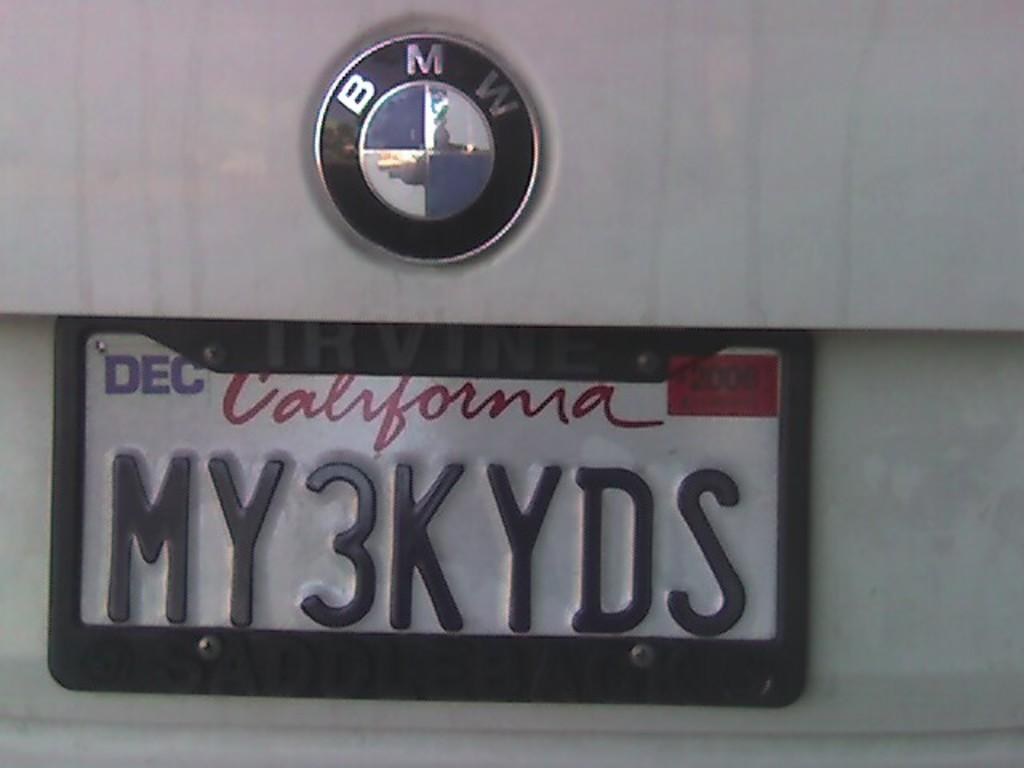<image>
Describe the image concisely. A California license place for a BMW says my3kyds. 